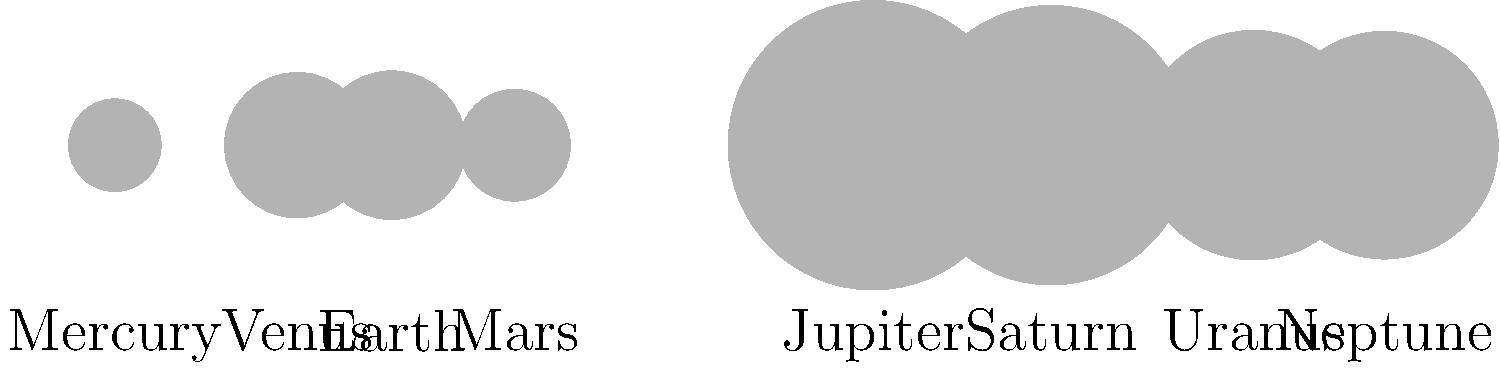In the context of international space cooperation, which planet's exploration would require the most extensive diplomatic negotiations due to its size and distance, potentially involving multiple countries' resources and expertise? To answer this question, we need to consider both the size and distance of the planets from the Sun. Let's analyze the information provided in the diagram:

1. Size: The diagram shows the relative sizes of the planets, with Jupiter and Saturn being the largest.
2. Distance: The x-axis represents the distance from the Sun (not to scale, but in order).

Step-by-step reasoning:

1. The largest planets are Jupiter and Saturn, which would require more resources to explore due to their size.
2. The most distant planets are Uranus and Neptune, which would require more advanced technology and longer mission durations.
3. Among these four planets, Jupiter stands out as the largest and the closest to Earth.
4. However, Neptune, being the farthest planet, would require the most extensive planning and resources for exploration.
5. Exploring Neptune would necessitate:
   a) Advanced propulsion systems to cover the vast distance
   b) Long-term life support systems for extended missions
   c) Sophisticated communication systems to maintain contact over extreme distances
   d) International collaboration to pool resources and expertise
6. The diplomatic challenges of coordinating such a complex mission across multiple countries would be significant.
7. The extended timeline of a Neptune mission would also require sustained diplomatic efforts over many years or even decades.

Therefore, Neptune's exploration would likely require the most extensive diplomatic negotiations due to its extreme distance and the complexity of the mission, despite not being the largest planet.
Answer: Neptune 